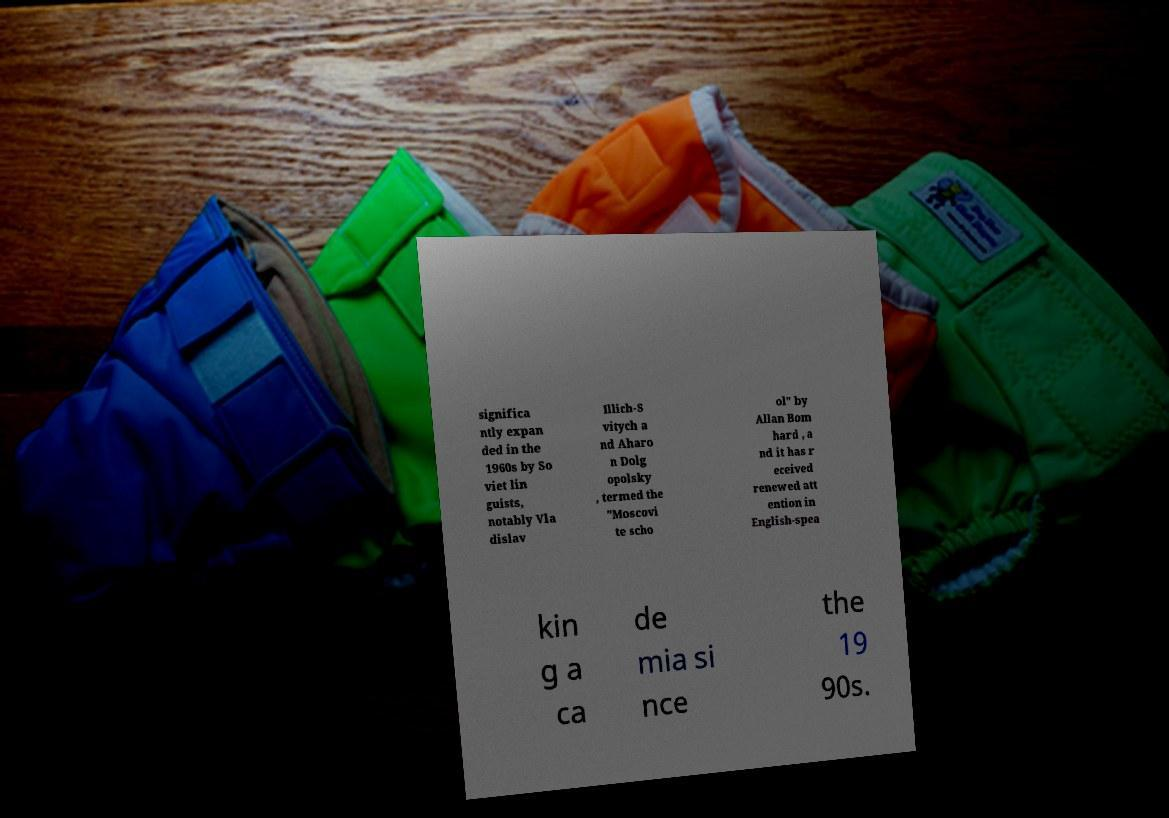Please read and relay the text visible in this image. What does it say? significa ntly expan ded in the 1960s by So viet lin guists, notably Vla dislav Illich-S vitych a nd Aharo n Dolg opolsky , termed the "Moscovi te scho ol" by Allan Bom hard , a nd it has r eceived renewed att ention in English-spea kin g a ca de mia si nce the 19 90s. 